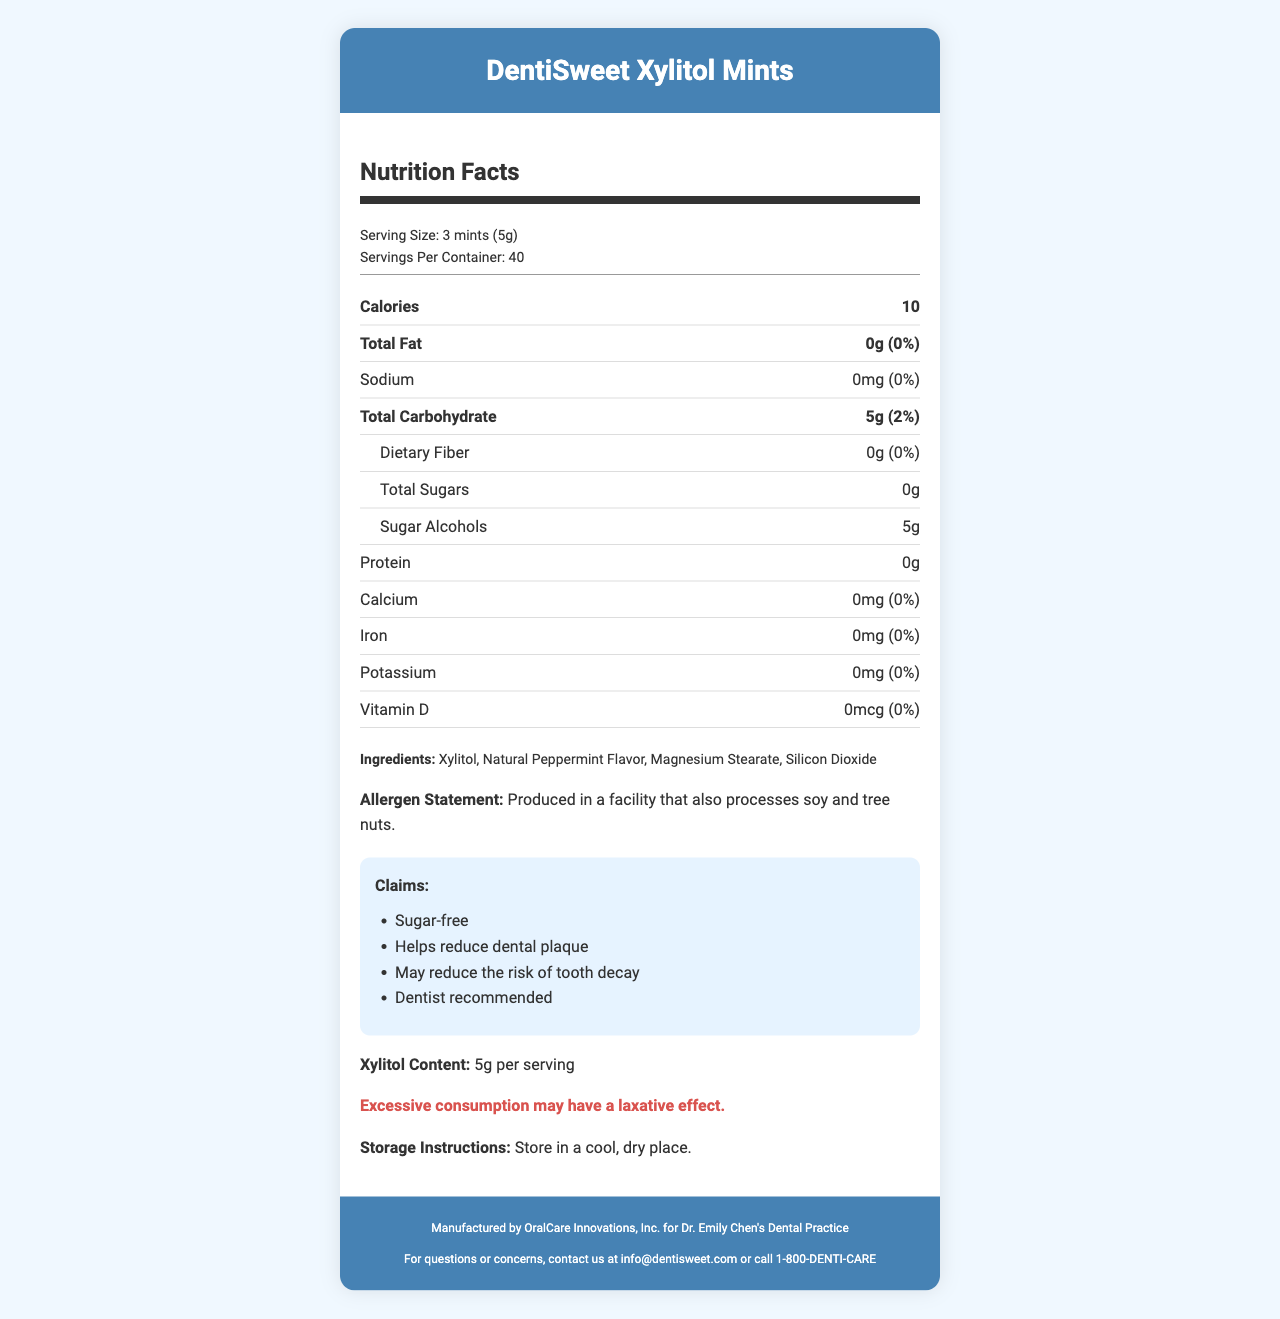what is the serving size for DentiSweet Xylitol Mints? The document lists the serving size as "3 mints (5g)".
Answer: 3 mints (5g) how many servings are in each container? The document states that there are 40 servings per container.
Answer: 40 how many calories are there per serving? The nutrition facts show that each serving has 10 calories.
Answer: 10 how much total carbohydrate is in a serving? According to the nutrition facts, there are 5g of total carbohydrates per serving, which is 2% of the daily value.
Answer: 5g (2%) what ingredients are in DentiSweet Xylitol Mints? The ingredients listed are Xylitol, Natural Peppermint Flavor, Magnesium Stearate, and Silicon Dioxide.
Answer: Xylitol, Natural Peppermint Flavor, Magnesium Stearate, Silicon Dioxide what are the claims made on the product? A. Sugar-free B. Helps reduce dental plaque C. Contains artificial sweeteners D. Dentist recommended E. May reduce the risk of tooth decay The claims listed are "Sugar-free", "Helps reduce dental plaque", "May reduce the risk of tooth decay", and "Dentist recommended".
Answer: A, B, D, E how much protein is in each serving? The nutrition facts indicate there is 0g of protein per serving.
Answer: 0g what is the warning statement on the product? The document includes a warning statement "Excessive consumption may have a laxative effect."
Answer: Excessive consumption may have a laxative effect. how should the product be stored? The storage instructions advise to "Store in a cool, dry place."
Answer: Store in a cool, dry place. who manufactures DentiSweet Xylitol Mints? The manufacturer information states that it's manufactured by OralCare Innovations, Inc. for Dr. Emily Chen's Dental Practice.
Answer: OralCare Innovations, Inc. for Dr. Emily Chen's Dental Practice does the product contain any sugars? The nutrition facts indicate that the total sugars amount is 0g.
Answer: No what is the main idea of the document? The document is a comprehensive Nutrition Facts Label for DentiSweet Xylitol Mints. It covers serving size, nutritional content, ingredients, claims, warnings, storage instructions, and manufacturer contact information, highlighting the product's benefits for dental health.
Answer: The document provides detailed nutritional information, ingredients, claims, and manufacturer details for DentiSweet Xylitol Mints, emphasizing its tooth-friendly benefits and sugar-free formulation. what health claims are made about the product? A. Improves vision B. Sugar-free C. Helps reduce dental plaque D. High in protein E. May reduce the risk of tooth decay The health claims listed in the document include "Sugar-free", "Helps reduce dental plaque", and "May reduce the risk of tooth decay".
Answer: B, C, E is the product recommended for dietary fiber intake? Yes/No The nutrition facts indicate 0g of dietary fiber, meaning the product is not a source of dietary fiber.
Answer: No how many grams of xylitol are in each serving? The document lists the xylitol content as 5g per serving.
Answer: 5g is there vitamin D in DentiSweet Xylitol Mints? The nutrition facts show that the amount of vitamin D is 0mcg, which means there's no vitamin D in the product.
Answer: No what is the manufacture date of the product? The document does not provide information regarding the manufacture date of DentiSweet Xylitol Mints.
Answer: Cannot be determined 